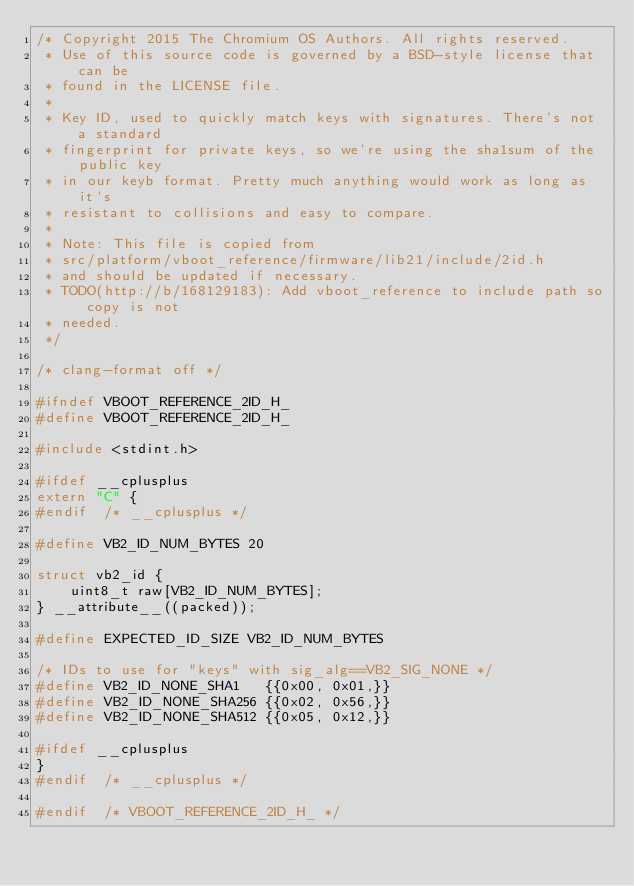<code> <loc_0><loc_0><loc_500><loc_500><_C_>/* Copyright 2015 The Chromium OS Authors. All rights reserved.
 * Use of this source code is governed by a BSD-style license that can be
 * found in the LICENSE file.
 *
 * Key ID, used to quickly match keys with signatures. There's not a standard
 * fingerprint for private keys, so we're using the sha1sum of the public key
 * in our keyb format. Pretty much anything would work as long as it's
 * resistant to collisions and easy to compare.
 *
 * Note: This file is copied from
 * src/platform/vboot_reference/firmware/lib21/include/2id.h
 * and should be updated if necessary.
 * TODO(http://b/168129183): Add vboot_reference to include path so copy is not
 * needed.
 */

/* clang-format off */

#ifndef VBOOT_REFERENCE_2ID_H_
#define VBOOT_REFERENCE_2ID_H_

#include <stdint.h>

#ifdef __cplusplus
extern "C" {
#endif  /* __cplusplus */

#define VB2_ID_NUM_BYTES 20

struct vb2_id {
	uint8_t raw[VB2_ID_NUM_BYTES];
} __attribute__((packed));

#define EXPECTED_ID_SIZE VB2_ID_NUM_BYTES

/* IDs to use for "keys" with sig_alg==VB2_SIG_NONE */
#define VB2_ID_NONE_SHA1   {{0x00, 0x01,}}
#define VB2_ID_NONE_SHA256 {{0x02, 0x56,}}
#define VB2_ID_NONE_SHA512 {{0x05, 0x12,}}

#ifdef __cplusplus
}
#endif  /* __cplusplus */

#endif  /* VBOOT_REFERENCE_2ID_H_ */
</code> 